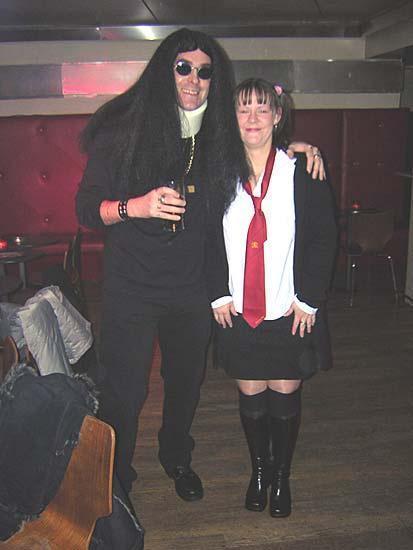How many chairs are in the photo?
Give a very brief answer. 2. How many people are visible?
Give a very brief answer. 2. How many bears are there?
Give a very brief answer. 0. 